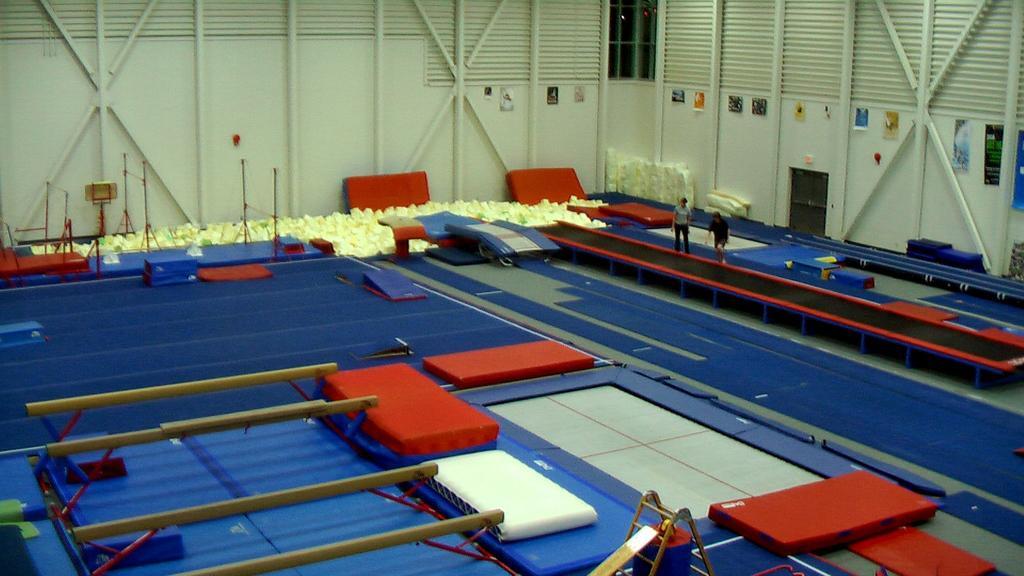How would you summarize this image in a sentence or two? In this image I can see number of gym mattresses, few poles and on the bottom side I can see a ladder. In the background I can see two persons are standing and I can also see number of posters on the wall. 